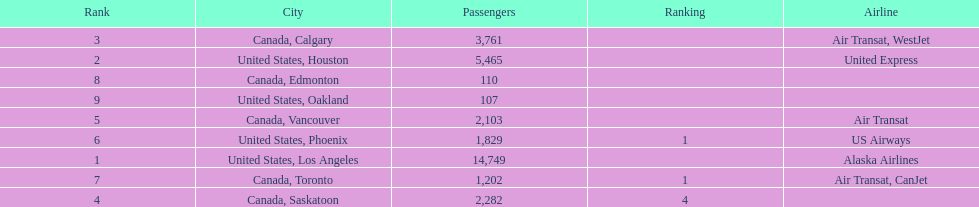Which canadian city had the most passengers traveling from manzanillo international airport in 2013? Calgary. 